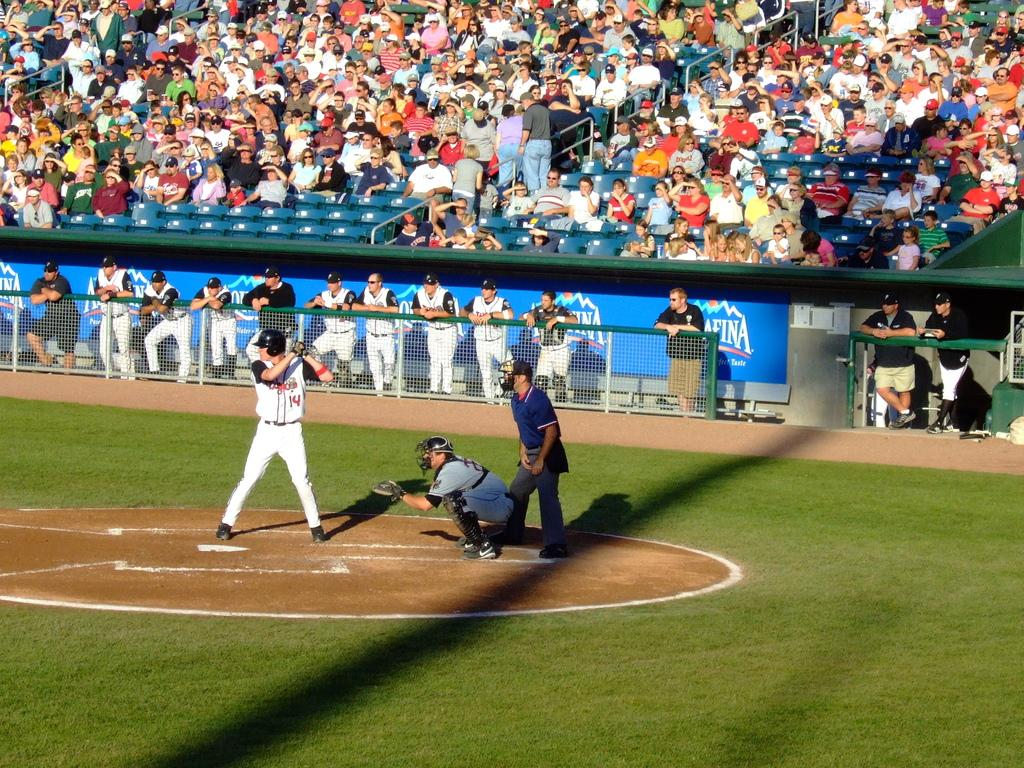Provide a one-sentence caption for the provided image. A man with a number 14 on his jersey prepares to hit a ball. 